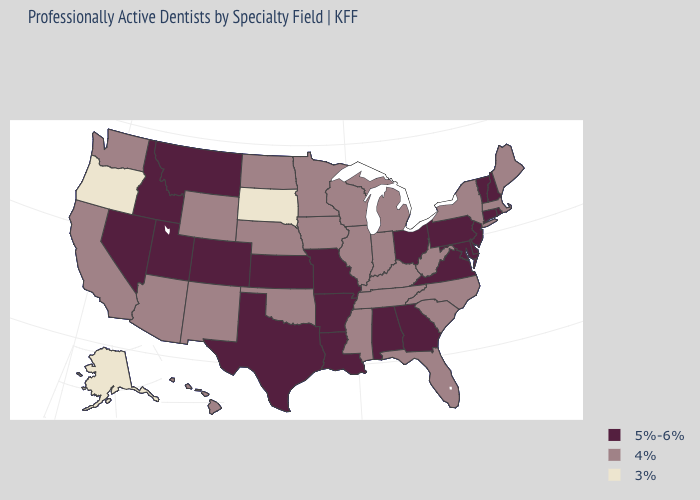Does Kentucky have a lower value than North Dakota?
Give a very brief answer. No. Among the states that border Idaho , does Nevada have the highest value?
Be succinct. Yes. Which states have the highest value in the USA?
Keep it brief. Alabama, Arkansas, Colorado, Connecticut, Delaware, Georgia, Idaho, Kansas, Louisiana, Maryland, Missouri, Montana, Nevada, New Hampshire, New Jersey, Ohio, Pennsylvania, Rhode Island, Texas, Utah, Vermont, Virginia. What is the value of Florida?
Be succinct. 4%. What is the highest value in the West ?
Keep it brief. 5%-6%. Name the states that have a value in the range 4%?
Answer briefly. Arizona, California, Florida, Hawaii, Illinois, Indiana, Iowa, Kentucky, Maine, Massachusetts, Michigan, Minnesota, Mississippi, Nebraska, New Mexico, New York, North Carolina, North Dakota, Oklahoma, South Carolina, Tennessee, Washington, West Virginia, Wisconsin, Wyoming. Among the states that border West Virginia , does Kentucky have the lowest value?
Quick response, please. Yes. What is the value of Pennsylvania?
Answer briefly. 5%-6%. What is the value of California?
Write a very short answer. 4%. What is the value of Oregon?
Concise answer only. 3%. What is the highest value in states that border New Hampshire?
Answer briefly. 5%-6%. What is the value of North Dakota?
Answer briefly. 4%. What is the value of Florida?
Be succinct. 4%. Name the states that have a value in the range 4%?
Concise answer only. Arizona, California, Florida, Hawaii, Illinois, Indiana, Iowa, Kentucky, Maine, Massachusetts, Michigan, Minnesota, Mississippi, Nebraska, New Mexico, New York, North Carolina, North Dakota, Oklahoma, South Carolina, Tennessee, Washington, West Virginia, Wisconsin, Wyoming. Among the states that border Oregon , which have the lowest value?
Be succinct. California, Washington. 